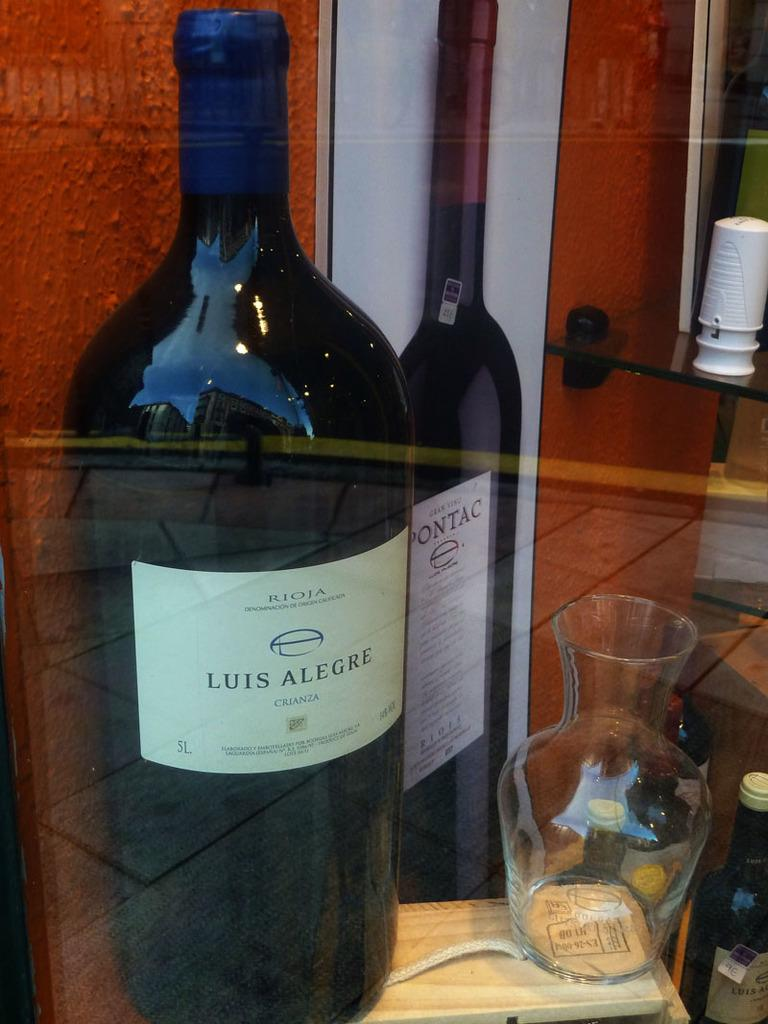<image>
Provide a brief description of the given image. A bottle of Luis Alegre wine sits behind a pane of glass. 